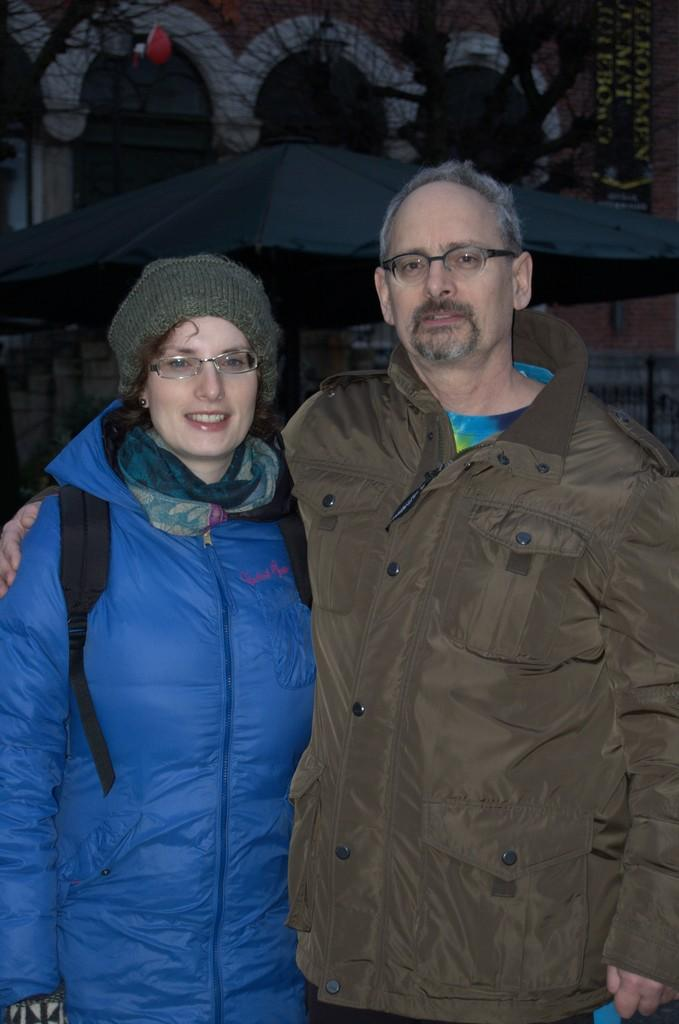How many people are present in the image? There are two people, a man and a woman, present in the image. What are the positions of the man and woman in the image? Both the man and woman are standing on the floor. What can be seen in the background of the image? There are buildings in the background of the image. What type of beam is the man holding in the image? There is no beam present in the image; the man is not holding anything. 